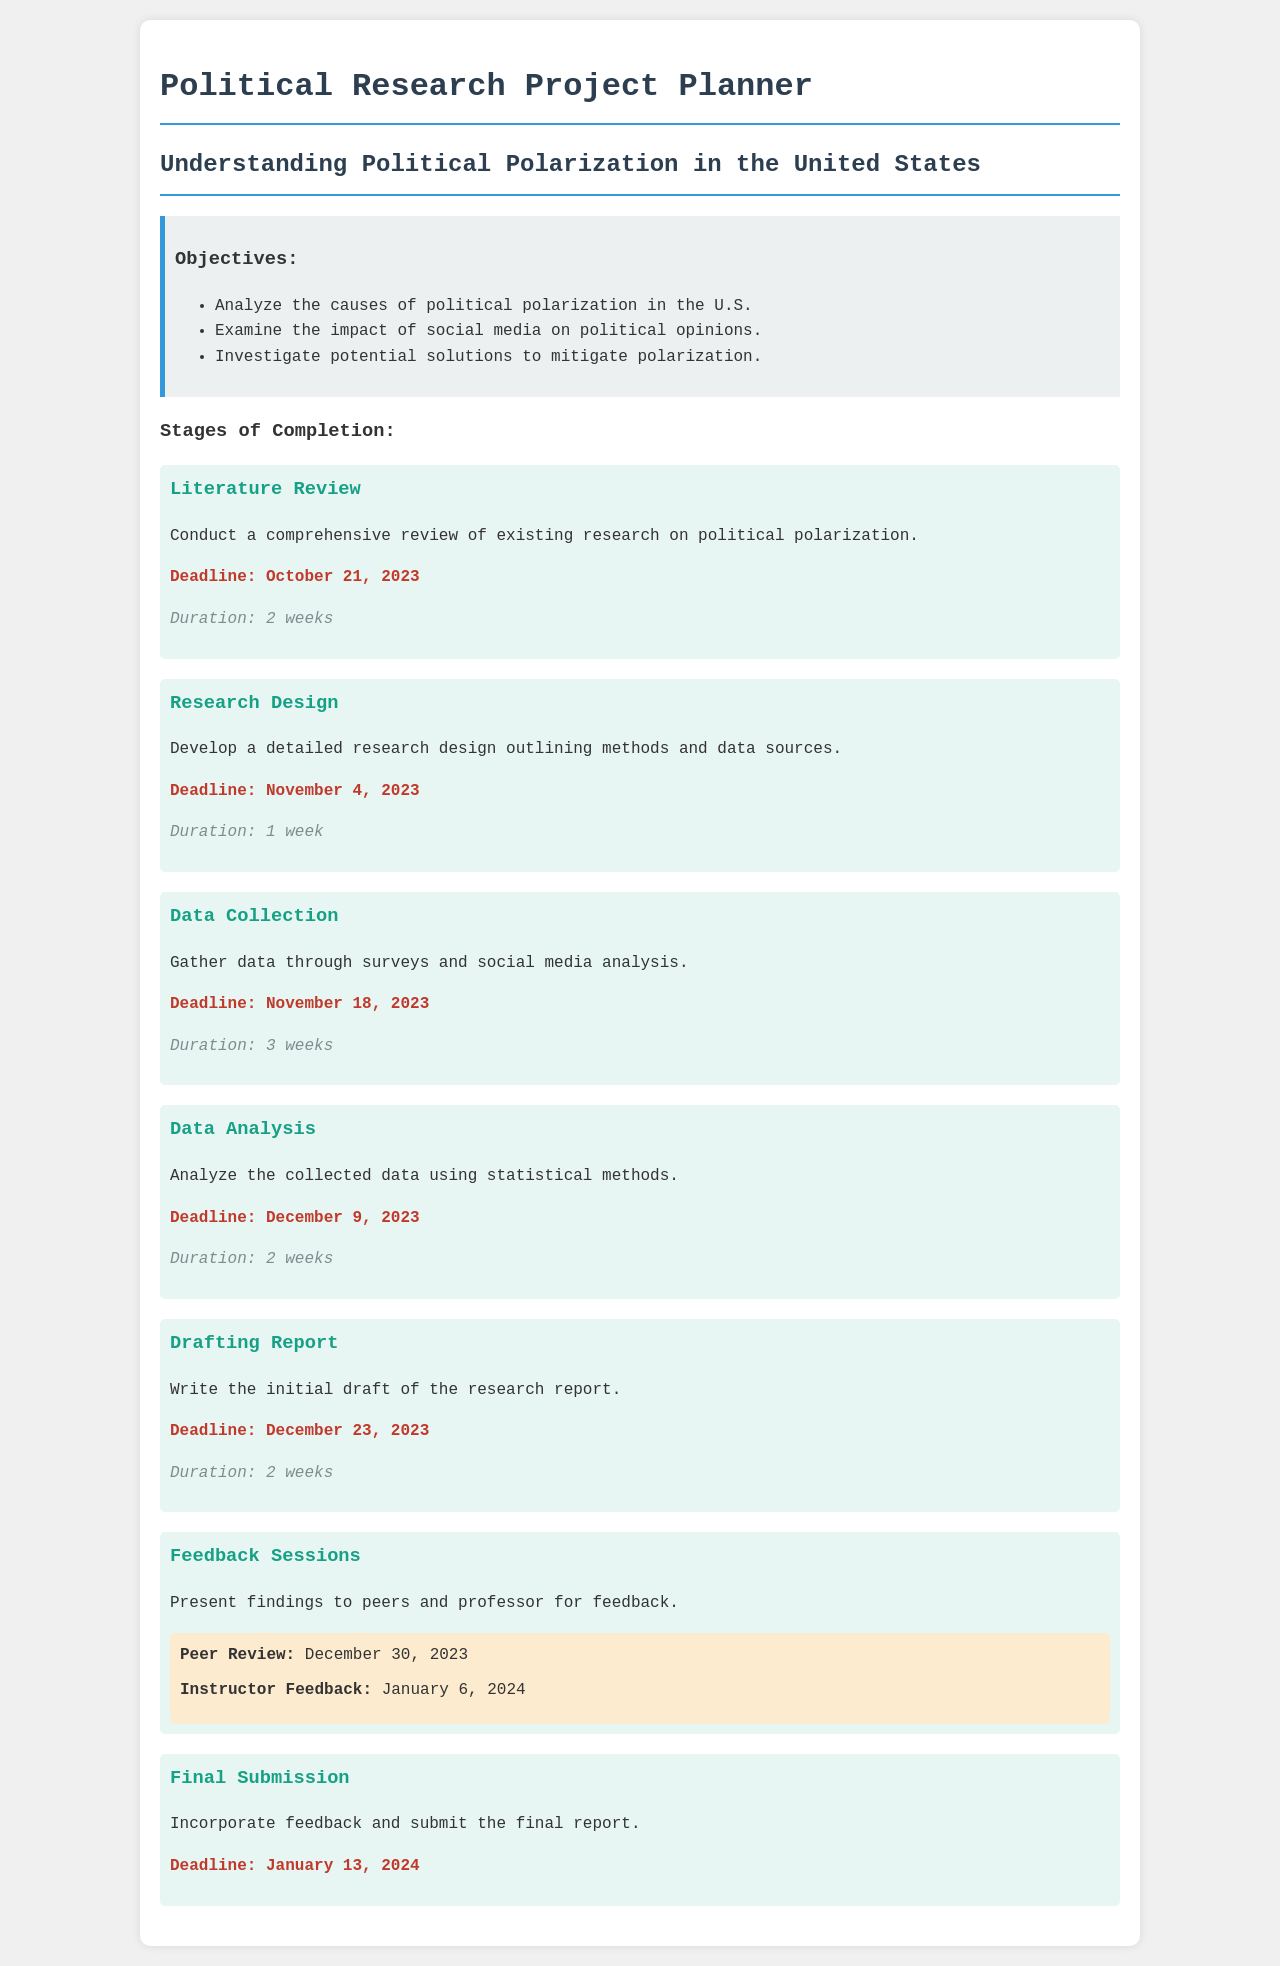What is the deadline for the Literature Review? The deadline for the Literature Review is clearly listed in the document as October 21, 2023.
Answer: October 21, 2023 How long is the duration for the Research Design stage? The duration for the Research Design stage is specified as 1 week in the document.
Answer: 1 week What is the main focus of the research project? The main focus is detailed under the title, which is "Understanding Political Polarization in the United States."
Answer: Understanding Political Polarization in the United States When is the Final Submission deadline? The Final Submission deadline is noted in the document as January 13, 2024.
Answer: January 13, 2024 What feedback session is scheduled for January 6, 2024? The document specifically states that Instructor Feedback is scheduled for January 6, 2024.
Answer: Instructor Feedback What is the total duration for the Data Collection stage? The total duration for the Data Collection stage is listed in the document as 3 weeks.
Answer: 3 weeks How many objectives are listed for the research project? The document outlines a total of 3 objectives related to the research project.
Answer: 3 What stage follows Data Analysis? The stage that follows Data Analysis, according to the document, is Drafting Report.
Answer: Drafting Report 